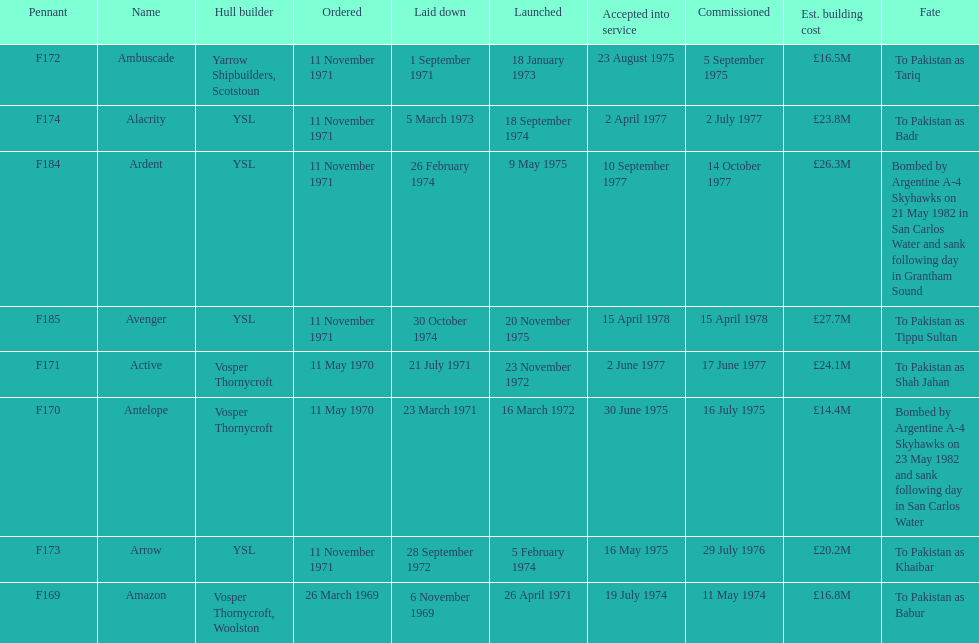What is the name of the ship listed after ardent? Avenger. 